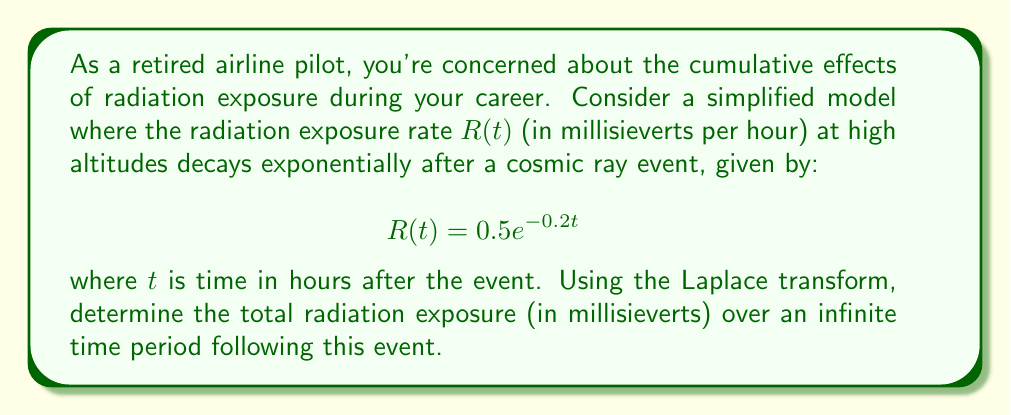Help me with this question. To solve this problem, we'll use the Laplace transform and its properties. Let's approach this step-by-step:

1) The Laplace transform of the radiation exposure rate $R(t)$ is given by:

   $$\mathcal{L}\{R(t)\} = \int_0^\infty R(t)e^{-st}dt$$

2) Substituting our function $R(t) = 0.5e^{-0.2t}$:

   $$\mathcal{L}\{R(t)\} = \int_0^\infty 0.5e^{-0.2t}e^{-st}dt = 0.5\int_0^\infty e^{-(s+0.2)t}dt$$

3) Evaluating this integral:

   $$\mathcal{L}\{R(t)\} = 0.5 \left[-\frac{1}{s+0.2}e^{-(s+0.2)t}\right]_0^\infty = 0.5 \cdot \frac{1}{s+0.2}$$

4) To find the total radiation exposure over an infinite time, we need to integrate $R(t)$ from 0 to infinity. In the Laplace domain, this is equivalent to evaluating $\mathcal{L}\{R(t)\}$ at $s=0$:

   $$\text{Total Exposure} = \lim_{s \to 0} \frac{0.5}{s+0.2} = \frac{0.5}{0.2} = 2.5$$

Thus, the total radiation exposure over an infinite time period is 2.5 millisieverts.
Answer: 2.5 millisieverts 